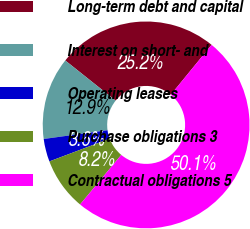<chart> <loc_0><loc_0><loc_500><loc_500><pie_chart><fcel>Long-term debt and capital<fcel>Interest on short- and<fcel>Operating leases<fcel>Purchase obligations 3<fcel>Contractual obligations 5<nl><fcel>25.2%<fcel>12.88%<fcel>3.57%<fcel>8.23%<fcel>50.12%<nl></chart> 